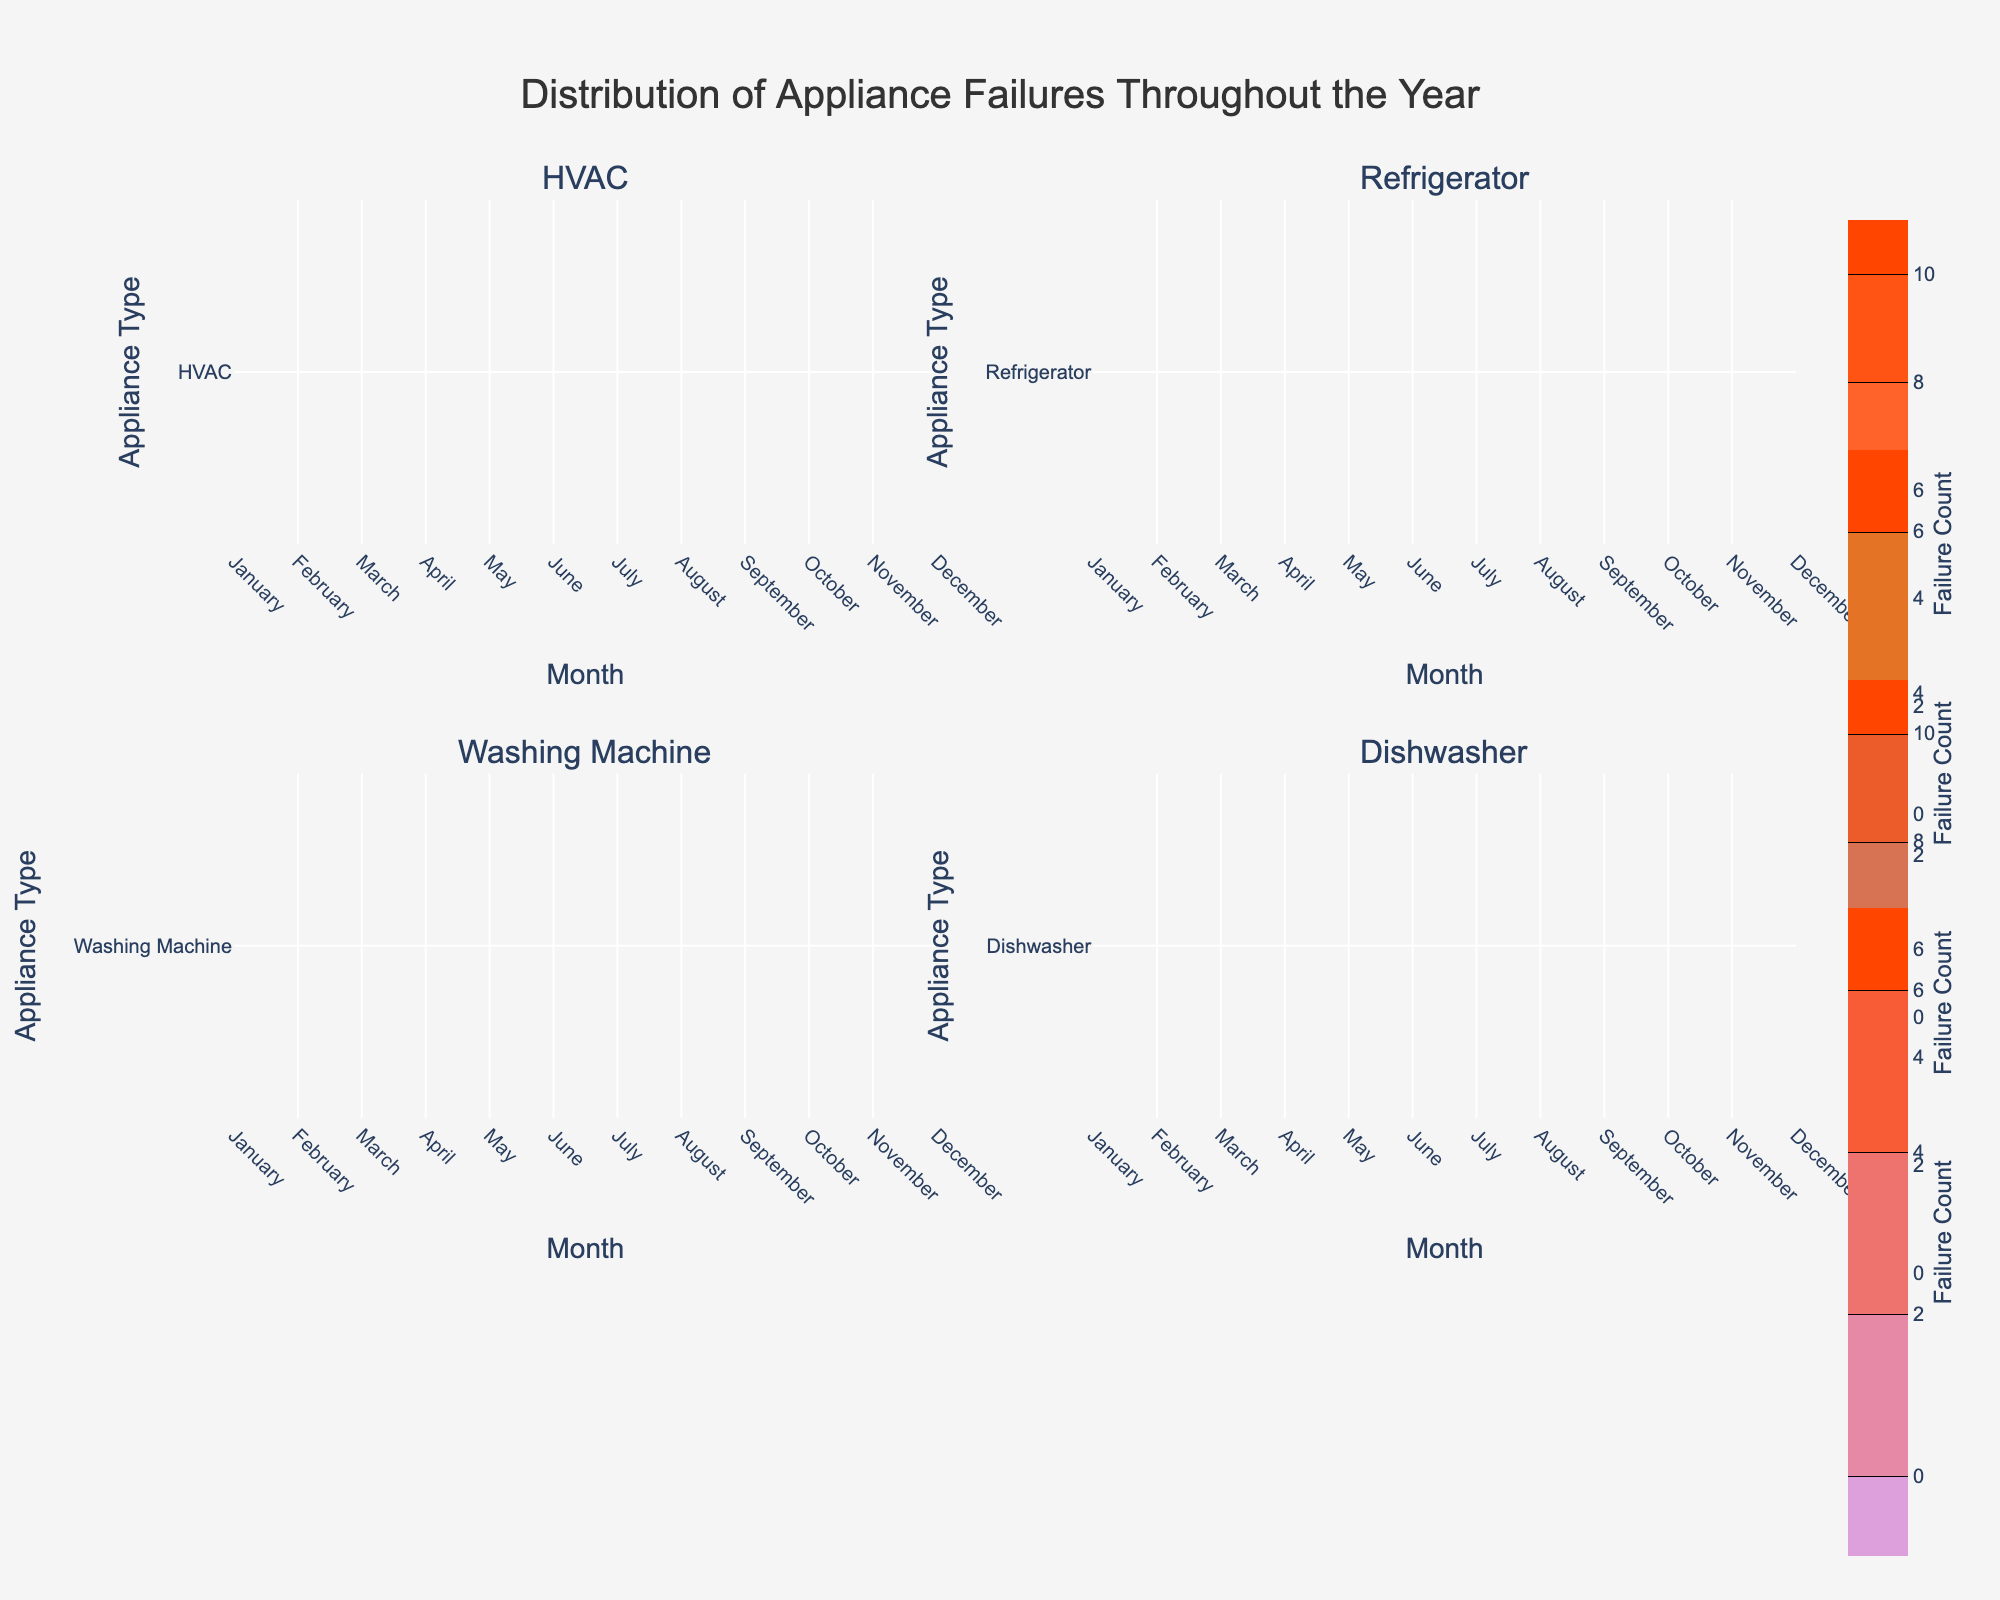What does the title of the figure say? The title is located at the top of the figure and is centered. It reads "Distribution of Appliance Failures Throughout the Year."
Answer: Distribution of Appliance Failures Throughout the Year What is the maximum Failure Count for the HVAC appliance? Locate the subplot for HVAC. The maximum value on the contour plot indicates the highest failure count, which is shown in July with a value of 10.
Answer: 10 How many subplots are in the figure? The figure grid is divided into four quadrants, each representing a different appliance type. Therefore, there are four subplots.
Answer: 4 What months have the highest failure counts for Washing Machine? Refer to the Washing Machine contour subplot. Contours with higher labels indicate higher failure counts. The highest values appear in April and May.
Answer: April and May Which appliance type has the most evenly distributed failure counts across the year? To determine even distribution, observe which contour plot appears most consistent throughout the year with minimal variation. The Refrigerator subplot shows a relatively even distribution without sharp peaks.
Answer: Refrigerator What is the difference in the maximum failure counts between HVAC and Dishwasher? Identify the maximum failure counts for each appliance type: HVAC has 10 in July, and Dishwasher has 7 in May. The difference is calculated as 10 - 7 = 3.
Answer: 3 In which month does the Dishwasher have its lowest failure count? Look at the Dishwasher contour subplot to find the lowest label. The month with the lowest failure count is September with a count of 2.
Answer: September Compare the failure counts for the HVAC and Refrigerator in February. Which has a higher count and by how much? From the HVAC and Refrigerator subplots, the failure counts in February are 7 for both appliances. The difference is 7 - 7 = 0, meaning they are equal.
Answer: They are equal, difference is 0 Are there any months where all appliance types share an equal failure count? Compare the contours across all four subplots for months where the same failure count appears for all appliances. No month shows equal failure counts for all four appliances simultaneously.
Answer: No Which appliance type has the highest peak failure in a single month? Examine the contour plots for each appliance: HVAC peaks at 10 in July, whereas all others peak lower. Therefore, HVAC has the highest peak failure count.
Answer: HVAC 